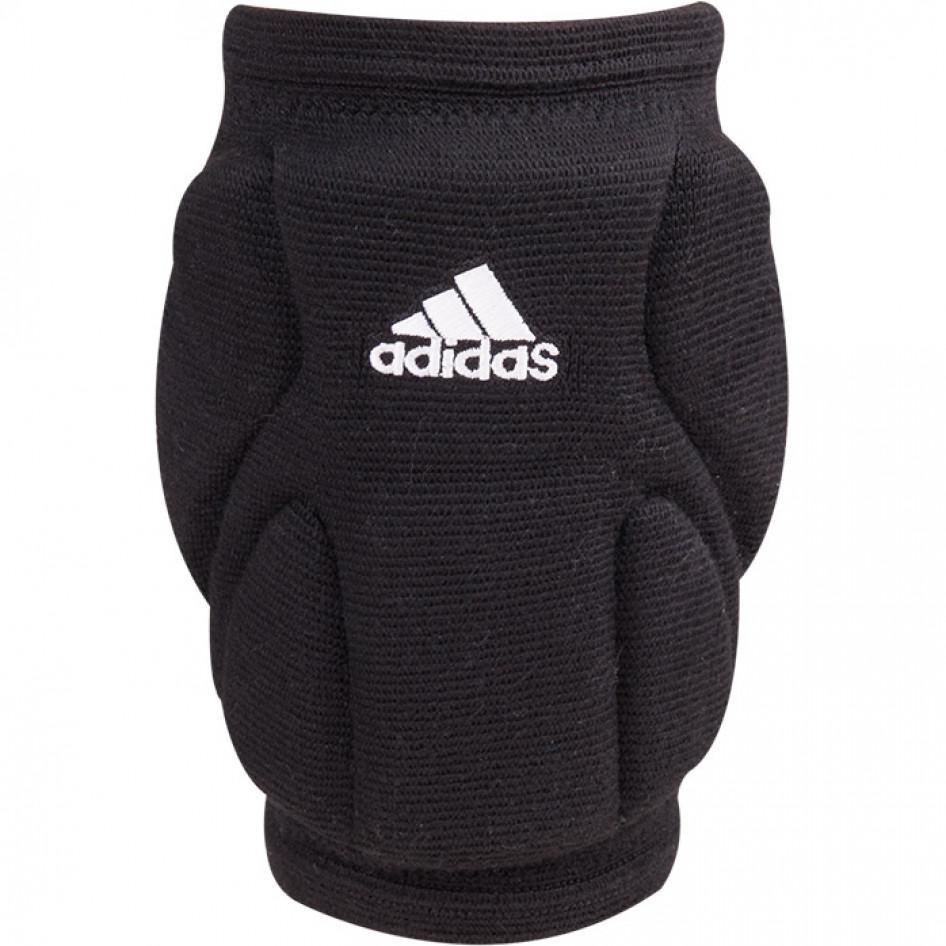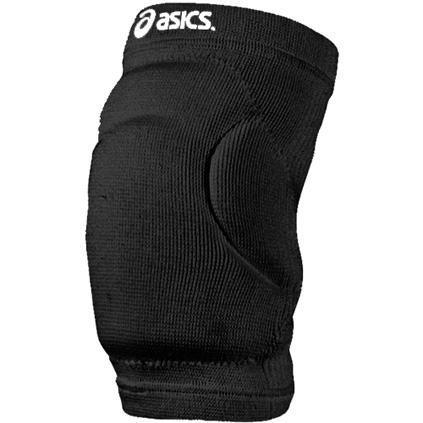The first image is the image on the left, the second image is the image on the right. Analyze the images presented: Is the assertion "A total of two knee pads without a knee opening are shown." valid? Answer yes or no. Yes. 